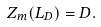Convert formula to latex. <formula><loc_0><loc_0><loc_500><loc_500>Z _ { m } ( L _ { D } ) = D .</formula> 